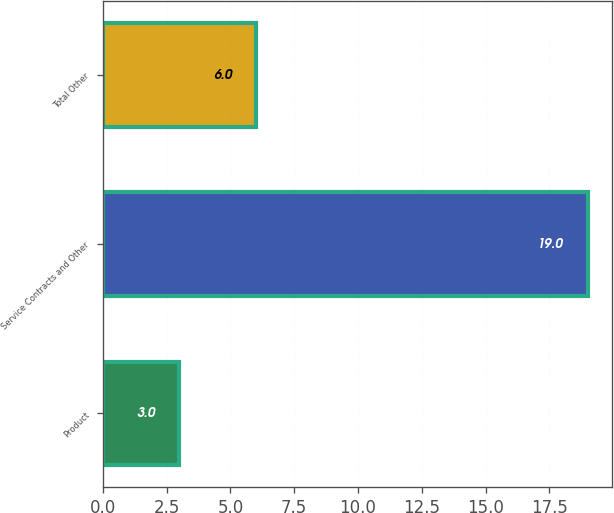<chart> <loc_0><loc_0><loc_500><loc_500><bar_chart><fcel>Product<fcel>Service Contracts and Other<fcel>Total Other<nl><fcel>3<fcel>19<fcel>6<nl></chart> 